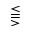Convert formula to latex. <formula><loc_0><loc_0><loc_500><loc_500>\leq s s e q q g t r</formula> 